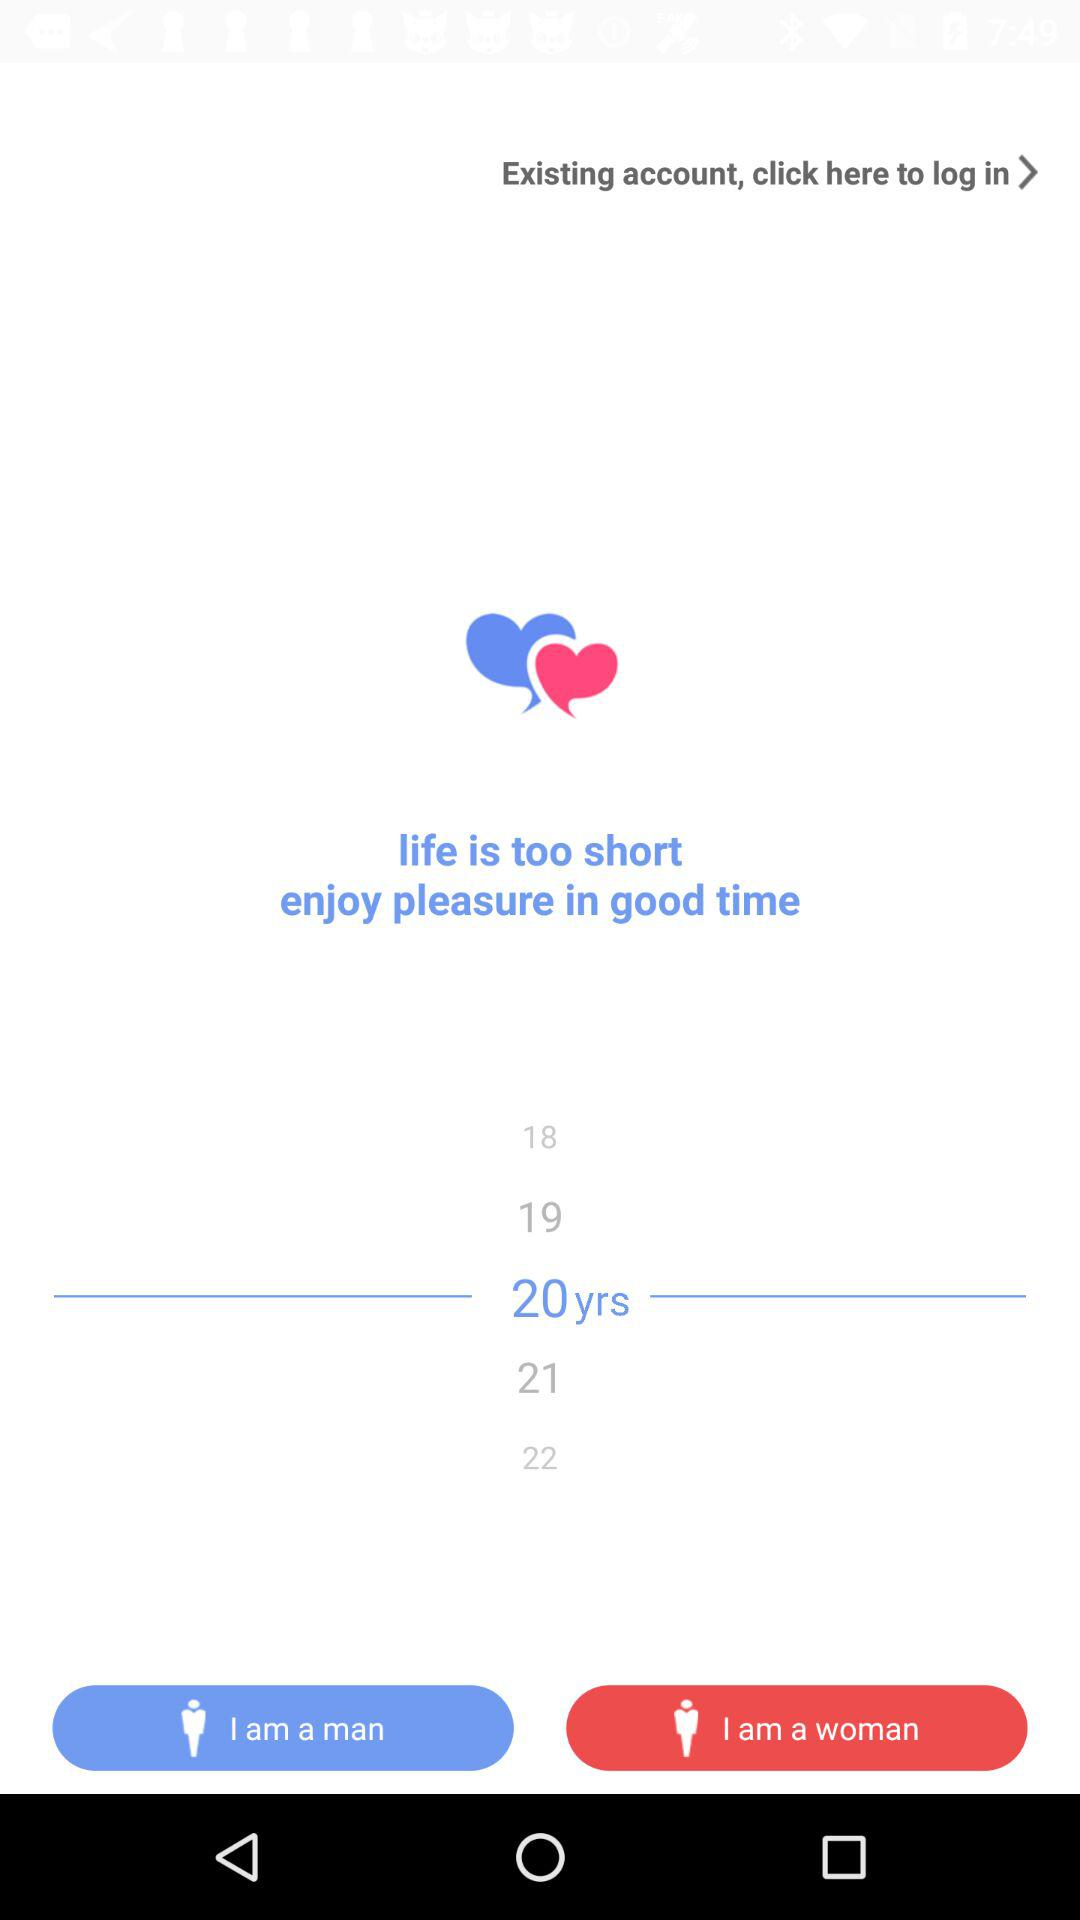What is the selected age? The selected age is 20 years. 